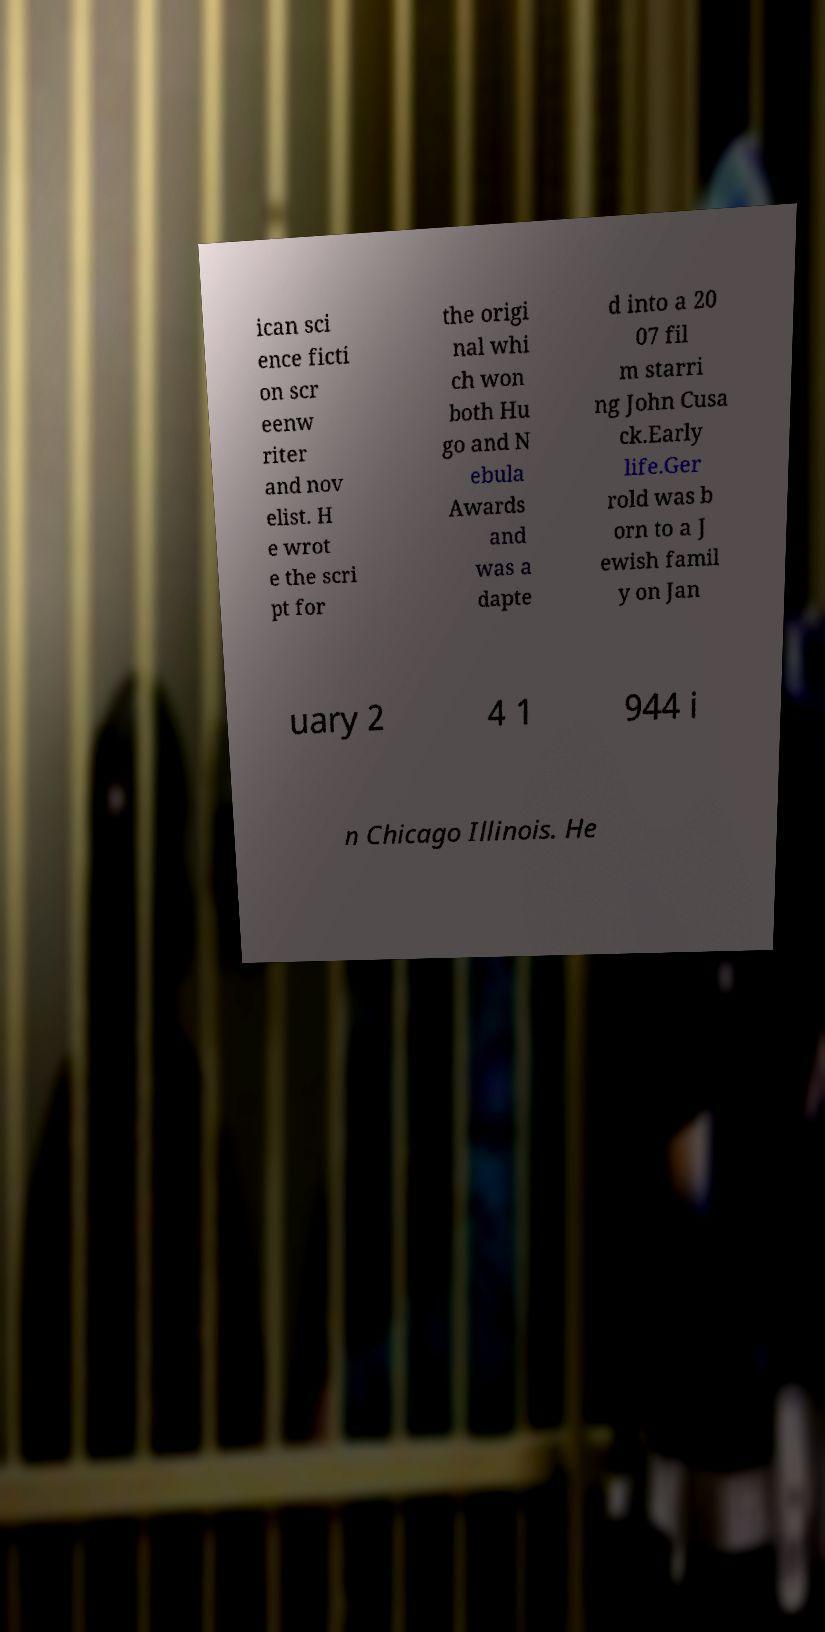Please read and relay the text visible in this image. What does it say? ican sci ence ficti on scr eenw riter and nov elist. H e wrot e the scri pt for the origi nal whi ch won both Hu go and N ebula Awards and was a dapte d into a 20 07 fil m starri ng John Cusa ck.Early life.Ger rold was b orn to a J ewish famil y on Jan uary 2 4 1 944 i n Chicago Illinois. He 